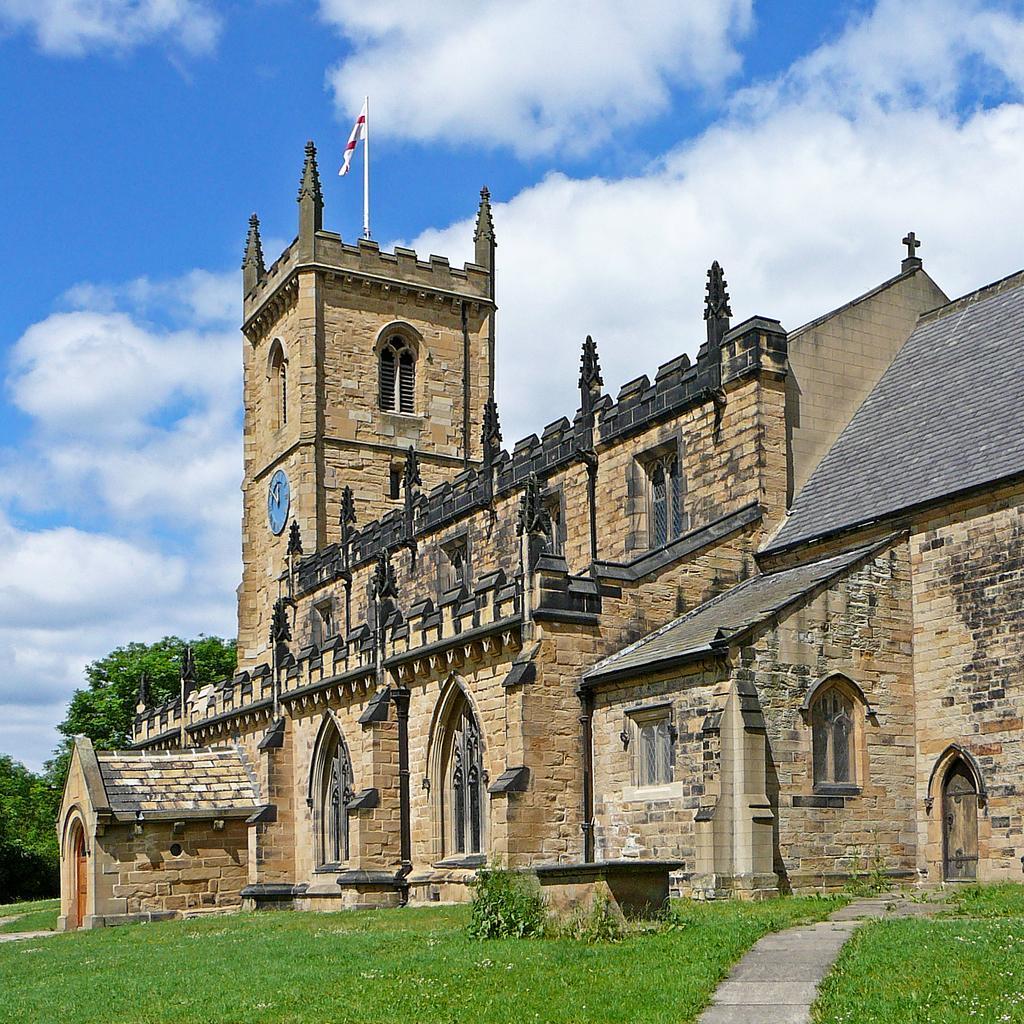Can you describe this image briefly? This is the picture of a building. In this image there is a building and there is a clock and flag on the building. At the back there are trees. At the top there is sky and there are clouds. At the bottom there is grass. 